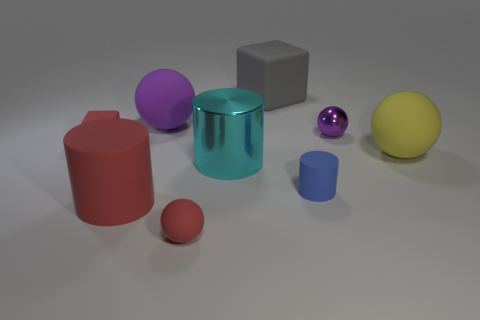Add 1 tiny cyan objects. How many objects exist? 10 Subtract all blocks. How many objects are left? 7 Subtract 0 gray cylinders. How many objects are left? 9 Subtract all small matte cylinders. Subtract all big gray blocks. How many objects are left? 7 Add 5 cylinders. How many cylinders are left? 8 Add 6 small rubber balls. How many small rubber balls exist? 7 